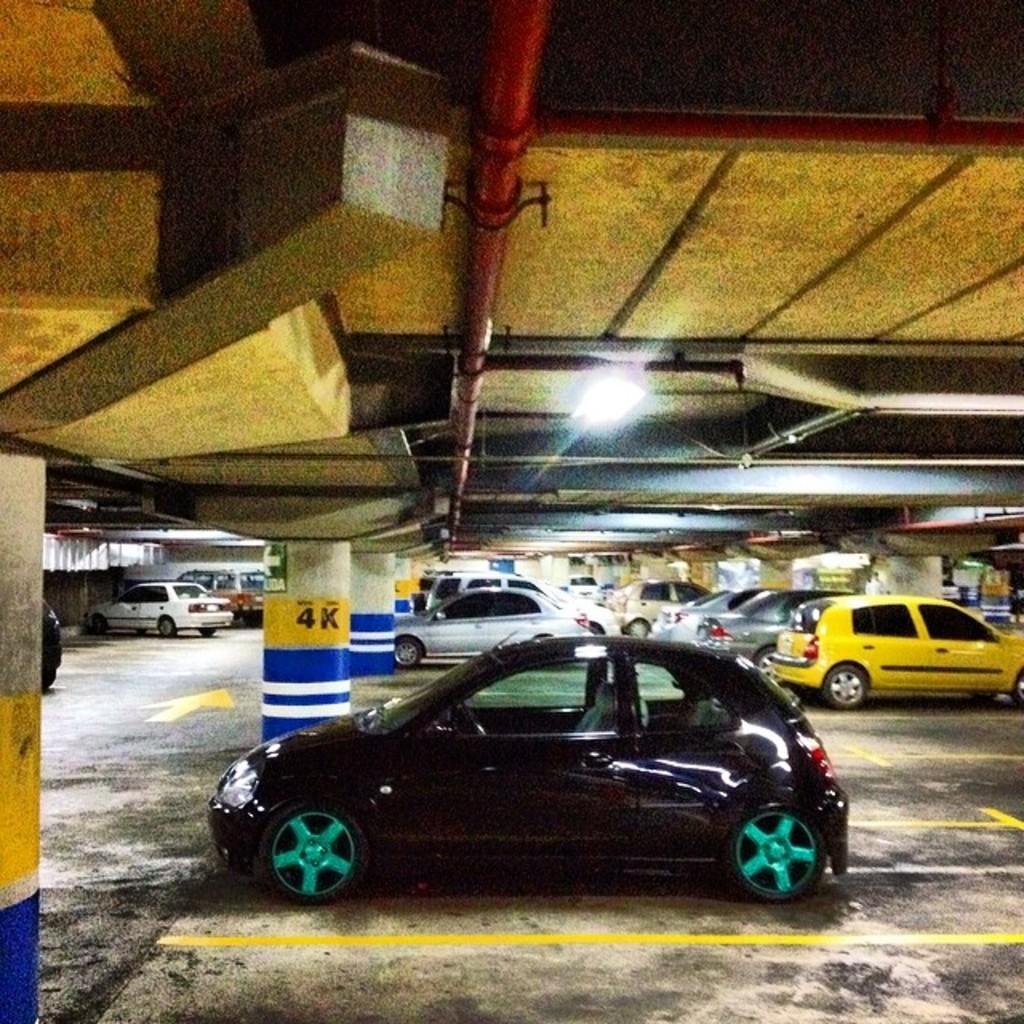In what row is this car parked?
Offer a very short reply. 4k. 